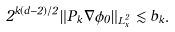<formula> <loc_0><loc_0><loc_500><loc_500>2 ^ { k ( d - 2 ) / 2 } \| P _ { k } \nabla \phi _ { 0 } \| _ { L ^ { 2 } _ { x } } \lesssim b _ { k } .</formula> 